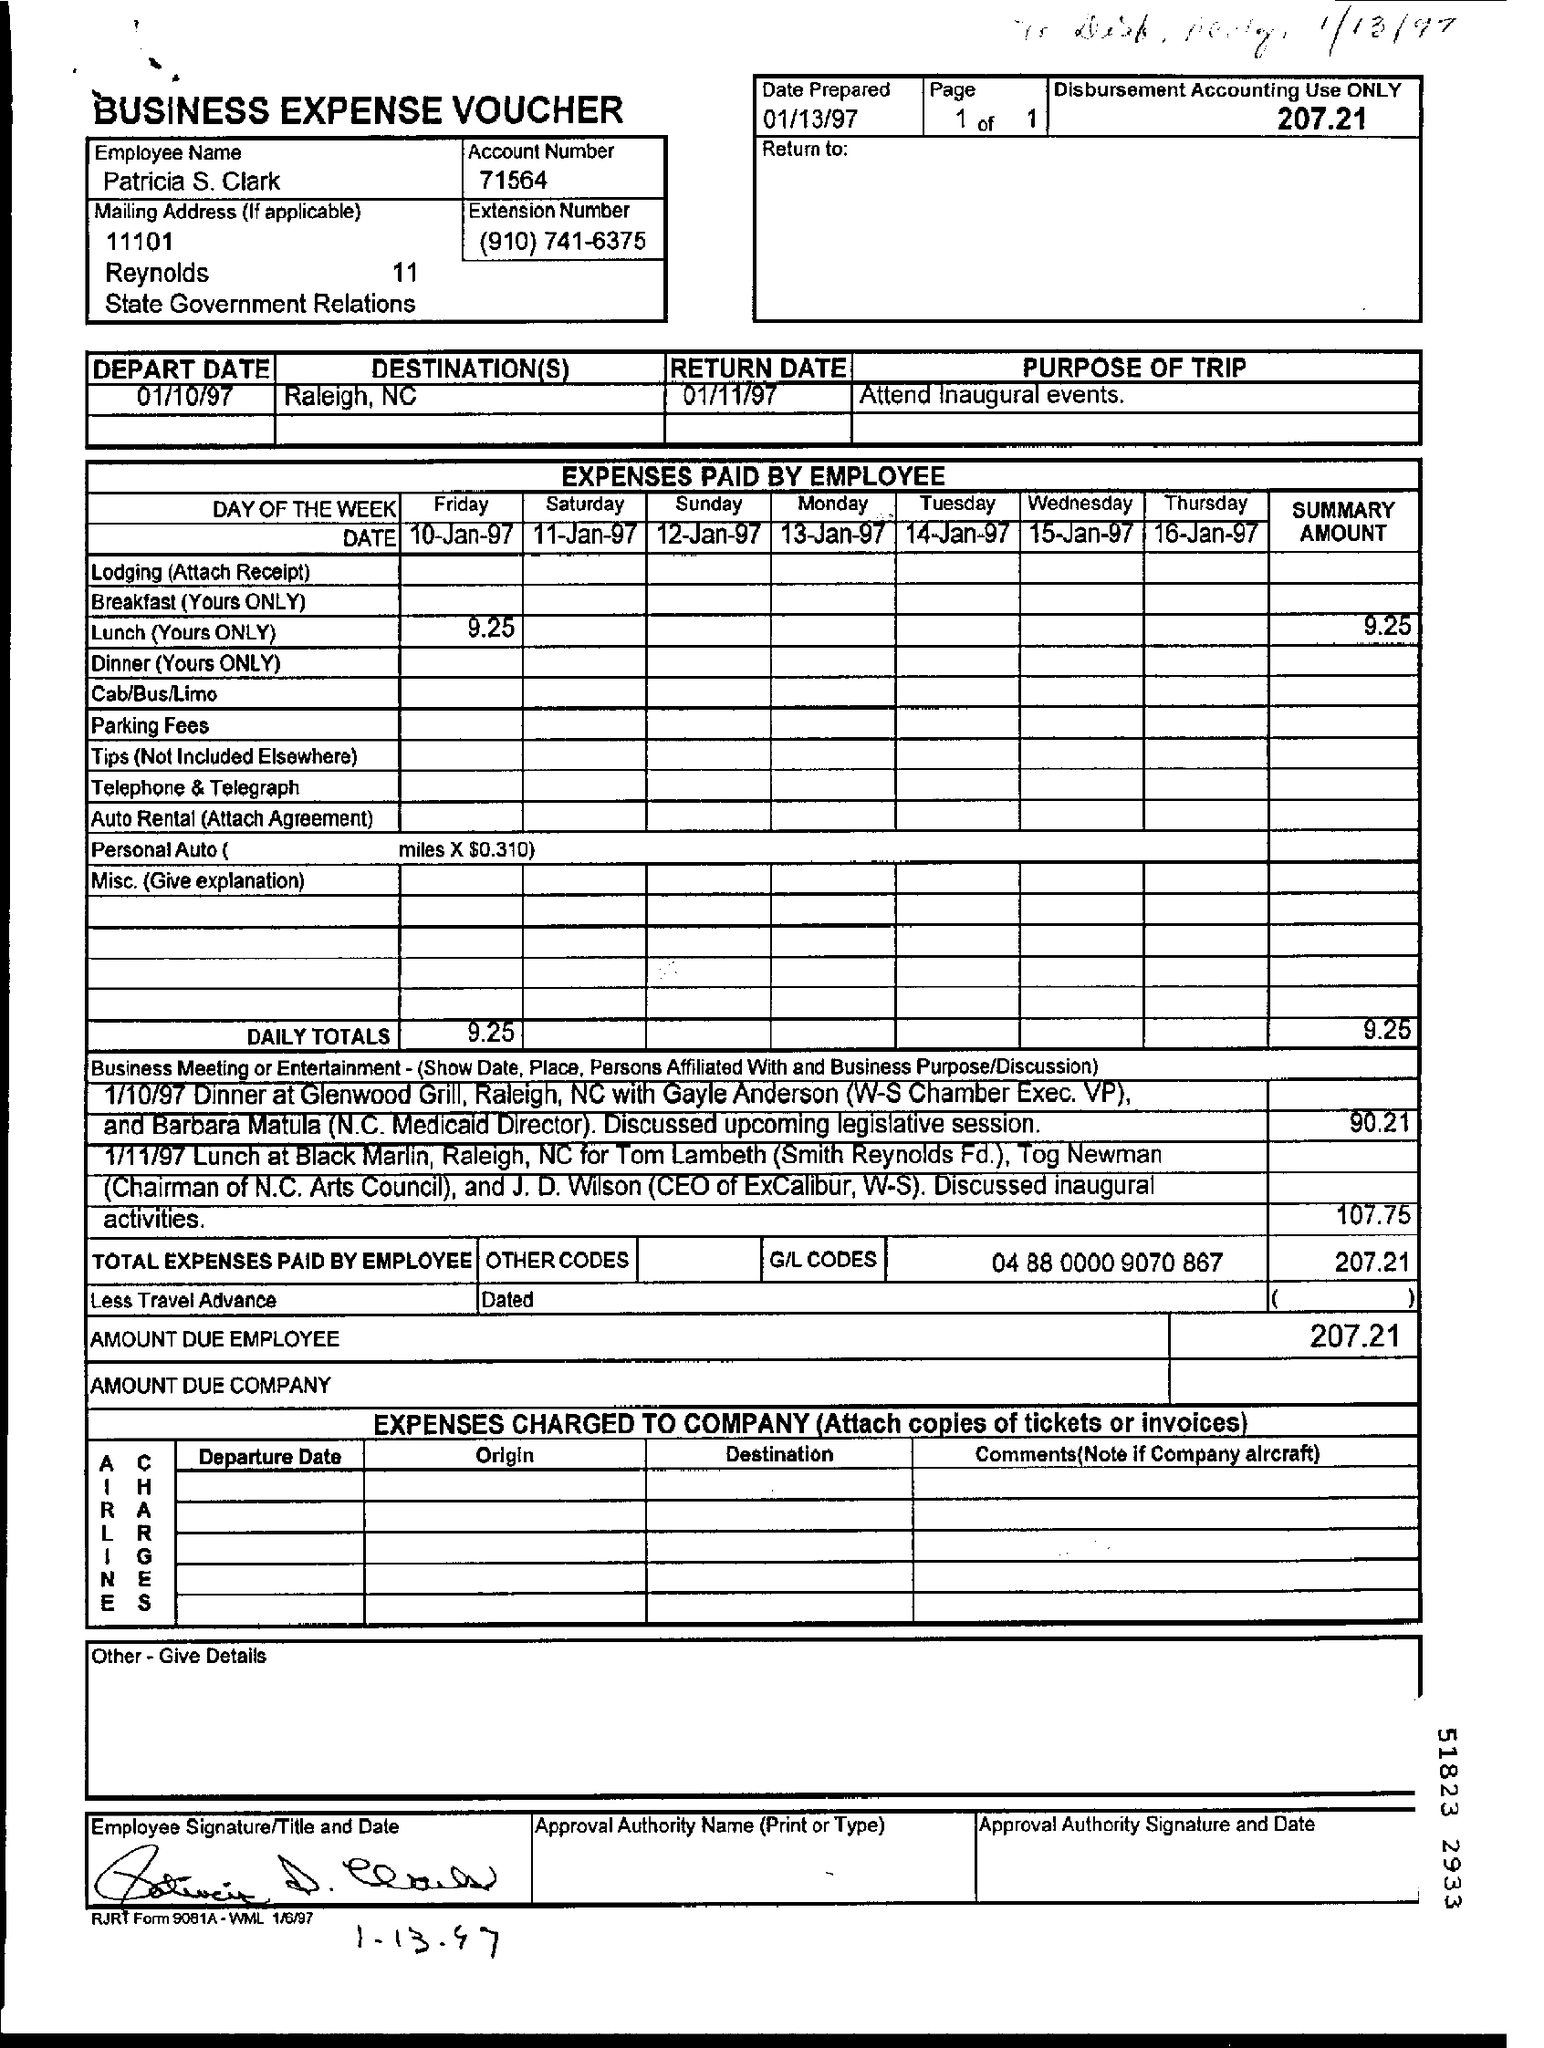Draw attention to some important aspects in this diagram. The amount due to the employee is 207.21 dollars and... The date prepared is January 13, 1997. The expense paid by an employee on Friday is 9.25. The account number is 71564... On what date did the departure occur? The departure date was 01/10/97. 